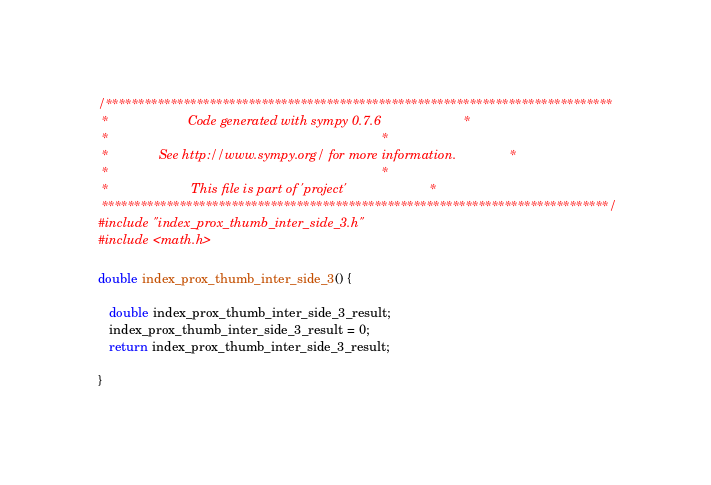Convert code to text. <code><loc_0><loc_0><loc_500><loc_500><_C_>/******************************************************************************
 *                      Code generated with sympy 0.7.6                       *
 *                                                                            *
 *              See http://www.sympy.org/ for more information.               *
 *                                                                            *
 *                       This file is part of 'project'                       *
 ******************************************************************************/
#include "index_prox_thumb_inter_side_3.h"
#include <math.h>

double index_prox_thumb_inter_side_3() {

   double index_prox_thumb_inter_side_3_result;
   index_prox_thumb_inter_side_3_result = 0;
   return index_prox_thumb_inter_side_3_result;

}
</code> 